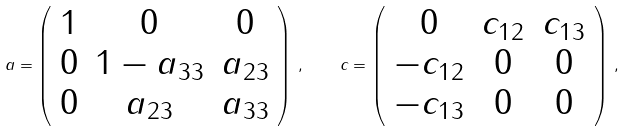<formula> <loc_0><loc_0><loc_500><loc_500>a = \left ( \begin{array} { c c c } 1 & 0 & 0 \\ 0 & 1 - a _ { 3 3 } & a _ { 2 3 } \\ 0 & a _ { 2 3 } & a _ { 3 3 } \end{array} \right ) \, , \quad c = \left ( \begin{array} { c c c } 0 & c _ { 1 2 } & c _ { 1 3 } \\ - c _ { 1 2 } & 0 & 0 \\ - c _ { 1 3 } & 0 & 0 \end{array} \right ) \, ,</formula> 